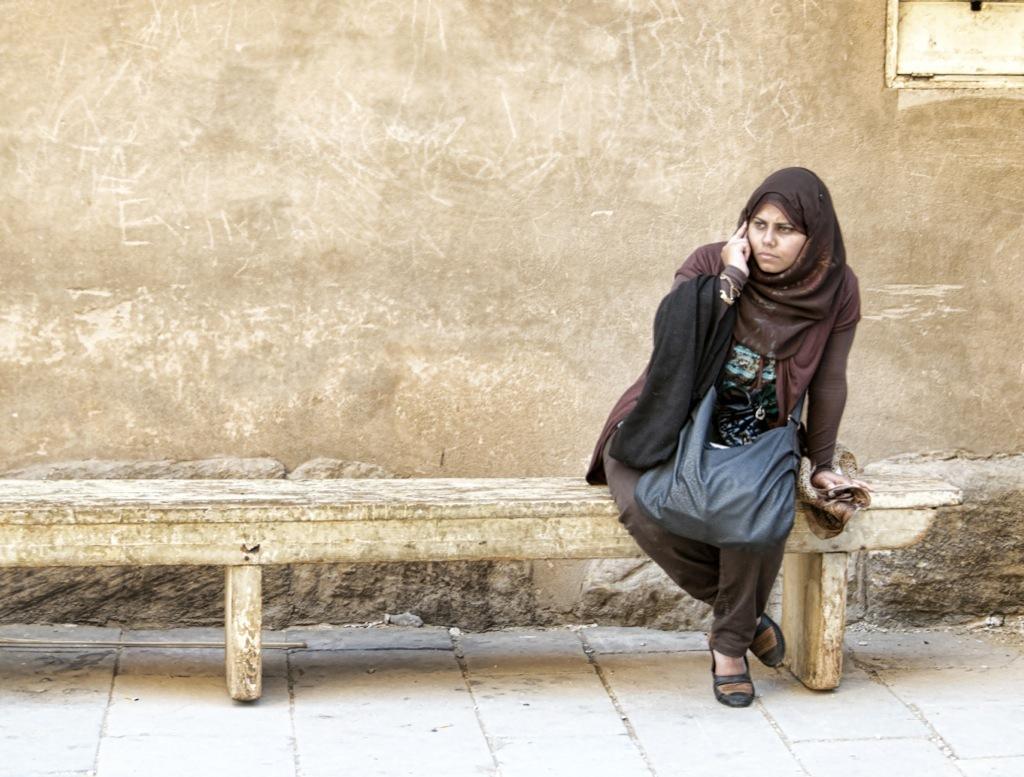Please provide a concise description of this image. In this image, I can see the woman sitting on a wooden bench. This is the wall. At the bottom of the image, I can see the floor. 